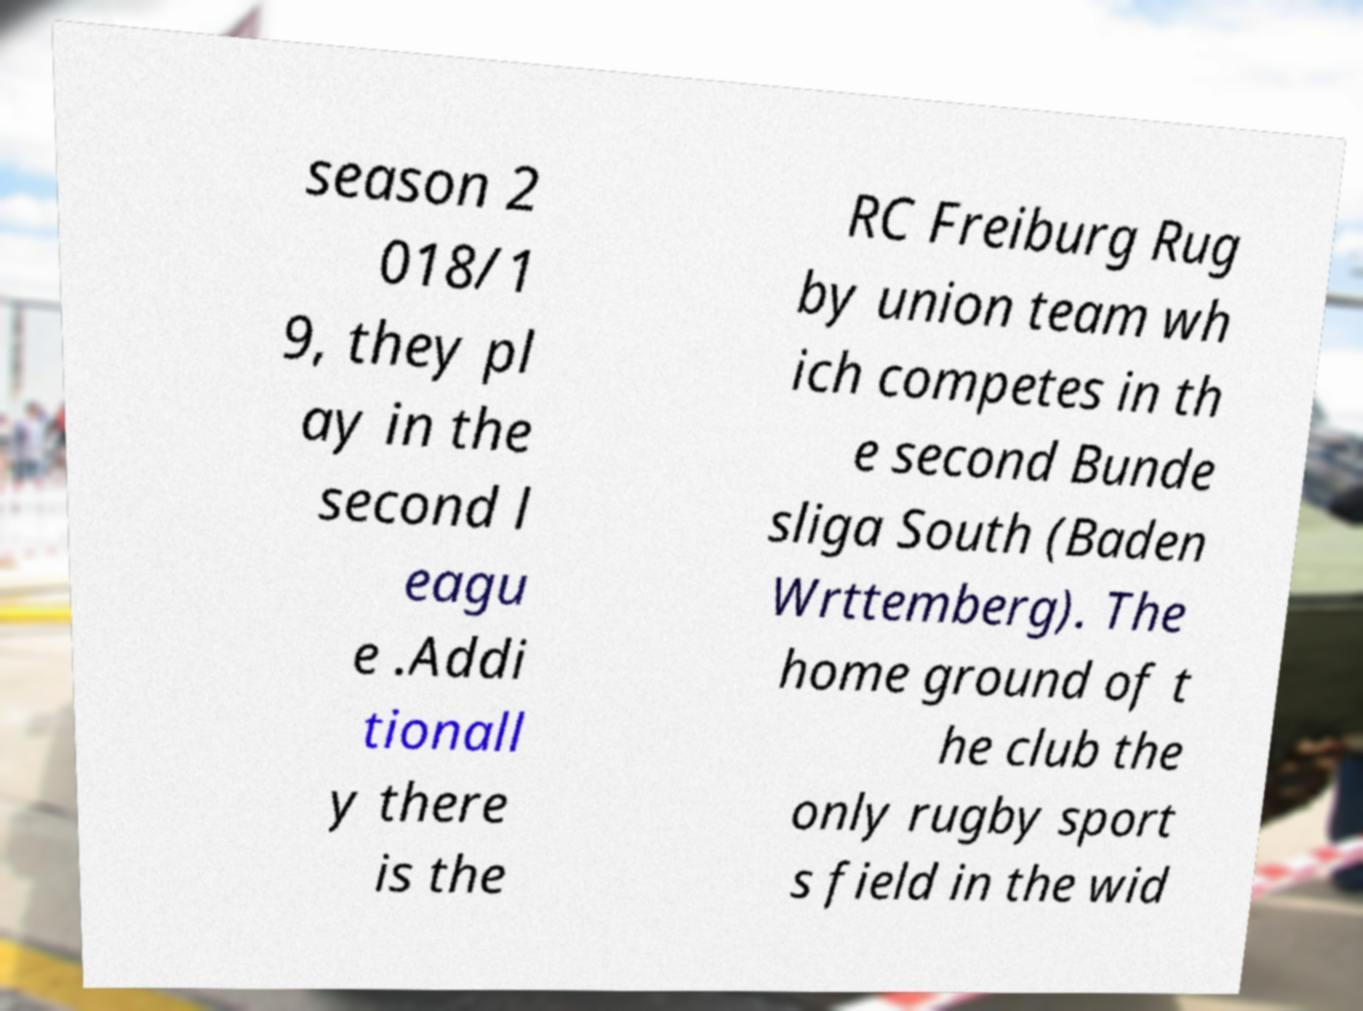I need the written content from this picture converted into text. Can you do that? season 2 018/1 9, they pl ay in the second l eagu e .Addi tionall y there is the RC Freiburg Rug by union team wh ich competes in th e second Bunde sliga South (Baden Wrttemberg). The home ground of t he club the only rugby sport s field in the wid 